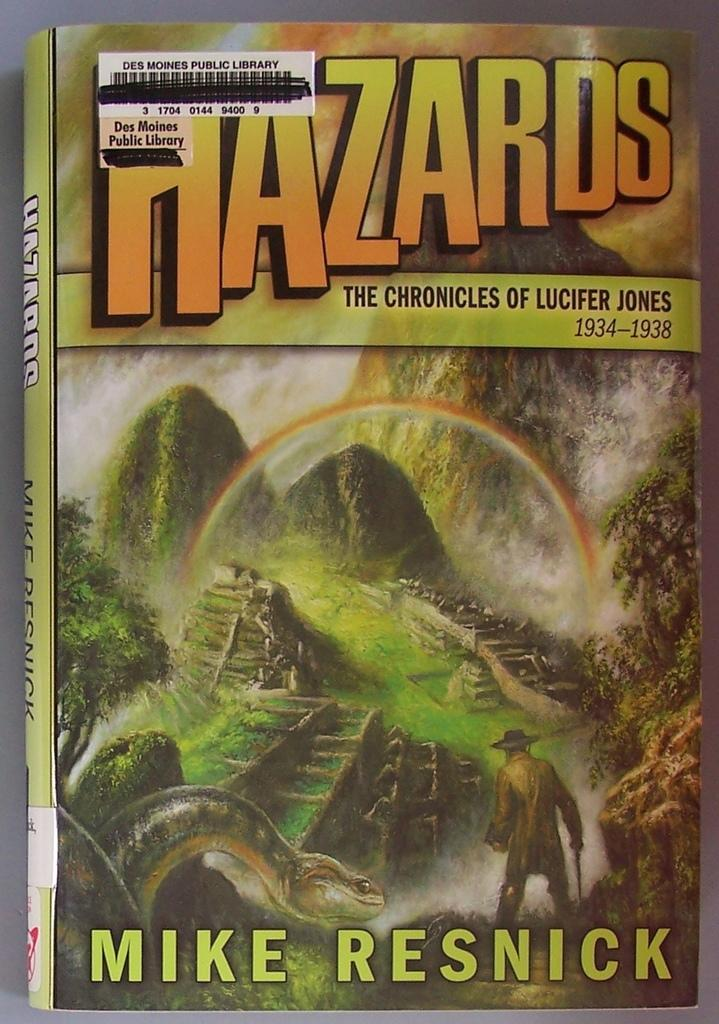<image>
Describe the image concisely. Cover of a book named Hazards by Mike Resnick. 